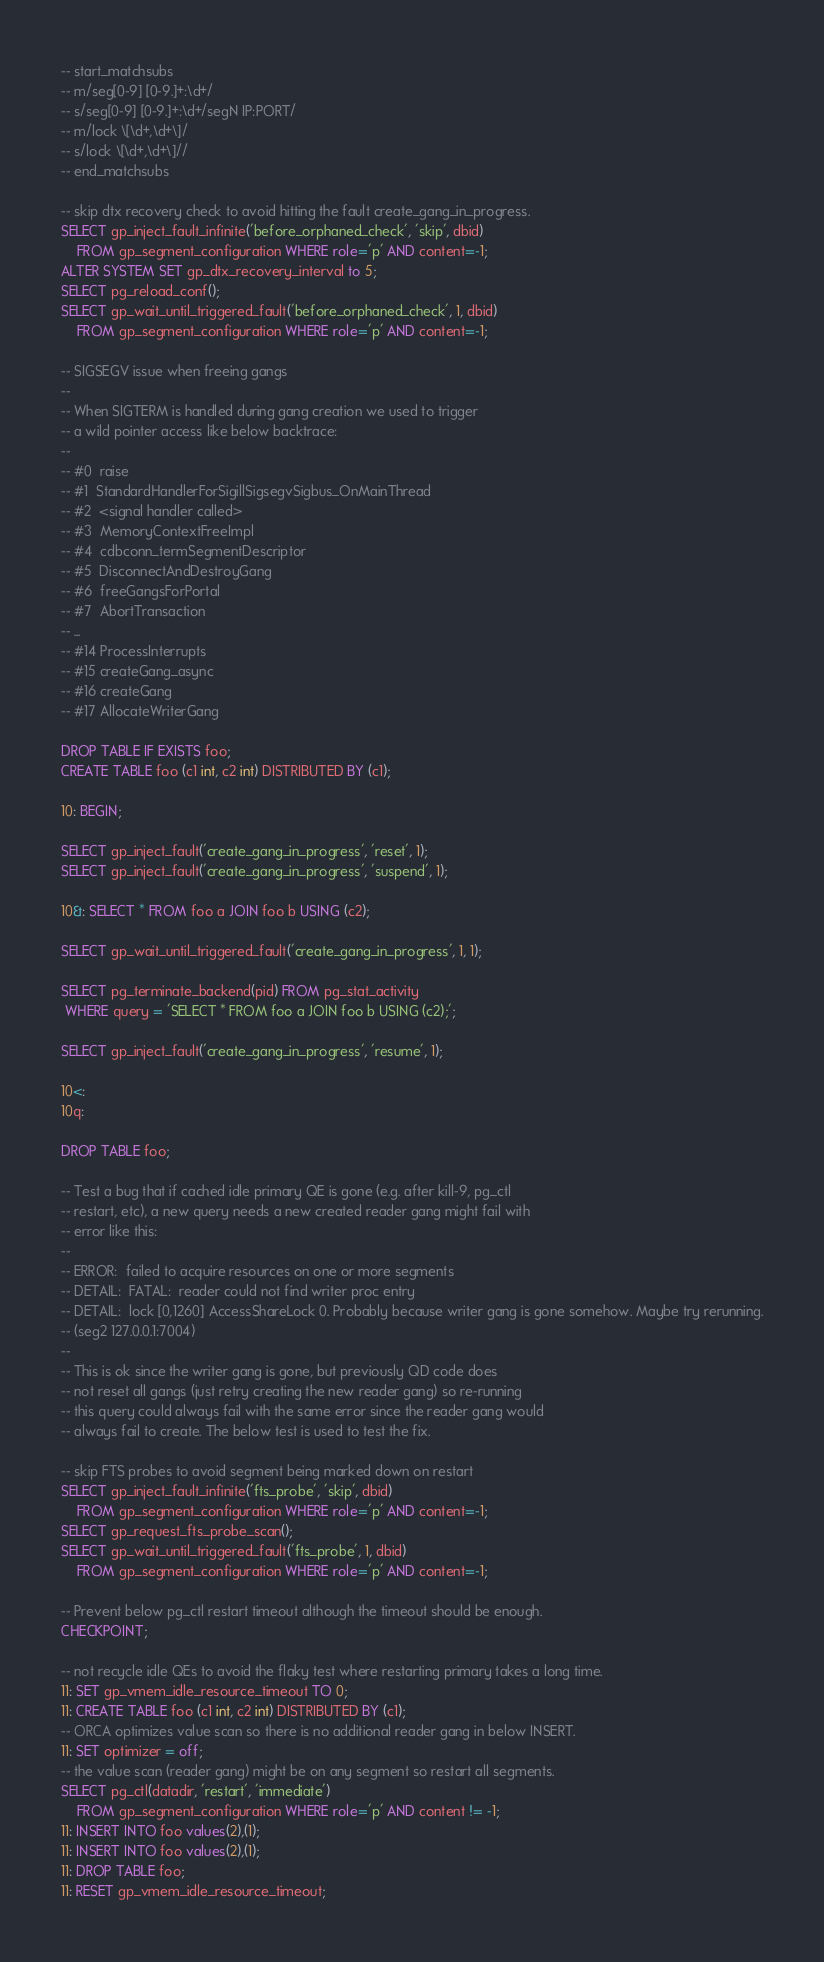<code> <loc_0><loc_0><loc_500><loc_500><_SQL_>-- start_matchsubs
-- m/seg[0-9] [0-9.]+:\d+/
-- s/seg[0-9] [0-9.]+:\d+/segN IP:PORT/
-- m/lock \[\d+,\d+\]/
-- s/lock \[\d+,\d+\]//
-- end_matchsubs

-- skip dtx recovery check to avoid hitting the fault create_gang_in_progress.
SELECT gp_inject_fault_infinite('before_orphaned_check', 'skip', dbid)
    FROM gp_segment_configuration WHERE role='p' AND content=-1;
ALTER SYSTEM SET gp_dtx_recovery_interval to 5;
SELECT pg_reload_conf();
SELECT gp_wait_until_triggered_fault('before_orphaned_check', 1, dbid)
    FROM gp_segment_configuration WHERE role='p' AND content=-1;

-- SIGSEGV issue when freeing gangs
--
-- When SIGTERM is handled during gang creation we used to trigger
-- a wild pointer access like below backtrace:
--
-- #0  raise
-- #1  StandardHandlerForSigillSigsegvSigbus_OnMainThread
-- #2  <signal handler called>
-- #3  MemoryContextFreeImpl
-- #4  cdbconn_termSegmentDescriptor
-- #5  DisconnectAndDestroyGang
-- #6  freeGangsForPortal
-- #7  AbortTransaction
-- ...
-- #14 ProcessInterrupts
-- #15 createGang_async
-- #16 createGang
-- #17 AllocateWriterGang

DROP TABLE IF EXISTS foo;
CREATE TABLE foo (c1 int, c2 int) DISTRIBUTED BY (c1);

10: BEGIN;

SELECT gp_inject_fault('create_gang_in_progress', 'reset', 1);
SELECT gp_inject_fault('create_gang_in_progress', 'suspend', 1);

10&: SELECT * FROM foo a JOIN foo b USING (c2);

SELECT gp_wait_until_triggered_fault('create_gang_in_progress', 1, 1);

SELECT pg_terminate_backend(pid) FROM pg_stat_activity
 WHERE query = 'SELECT * FROM foo a JOIN foo b USING (c2);';

SELECT gp_inject_fault('create_gang_in_progress', 'resume', 1);

10<:
10q:

DROP TABLE foo;

-- Test a bug that if cached idle primary QE is gone (e.g. after kill-9, pg_ctl
-- restart, etc), a new query needs a new created reader gang might fail with
-- error like this:
--
-- ERROR:  failed to acquire resources on one or more segments
-- DETAIL:  FATAL:  reader could not find writer proc entry
-- DETAIL:  lock [0,1260] AccessShareLock 0. Probably because writer gang is gone somehow. Maybe try rerunning.
-- (seg2 127.0.0.1:7004)
--
-- This is ok since the writer gang is gone, but previously QD code does
-- not reset all gangs (just retry creating the new reader gang) so re-running
-- this query could always fail with the same error since the reader gang would
-- always fail to create. The below test is used to test the fix.

-- skip FTS probes to avoid segment being marked down on restart
SELECT gp_inject_fault_infinite('fts_probe', 'skip', dbid)
    FROM gp_segment_configuration WHERE role='p' AND content=-1;
SELECT gp_request_fts_probe_scan();
SELECT gp_wait_until_triggered_fault('fts_probe', 1, dbid)
    FROM gp_segment_configuration WHERE role='p' AND content=-1;

-- Prevent below pg_ctl restart timeout although the timeout should be enough.
CHECKPOINT;

-- not recycle idle QEs to avoid the flaky test where restarting primary takes a long time.
11: SET gp_vmem_idle_resource_timeout TO 0;
11: CREATE TABLE foo (c1 int, c2 int) DISTRIBUTED BY (c1);
-- ORCA optimizes value scan so there is no additional reader gang in below INSERT.
11: SET optimizer = off;
-- the value scan (reader gang) might be on any segment so restart all segments.
SELECT pg_ctl(datadir, 'restart', 'immediate')
	FROM gp_segment_configuration WHERE role='p' AND content != -1;
11: INSERT INTO foo values(2),(1);
11: INSERT INTO foo values(2),(1);
11: DROP TABLE foo;
11: RESET gp_vmem_idle_resource_timeout;
</code> 